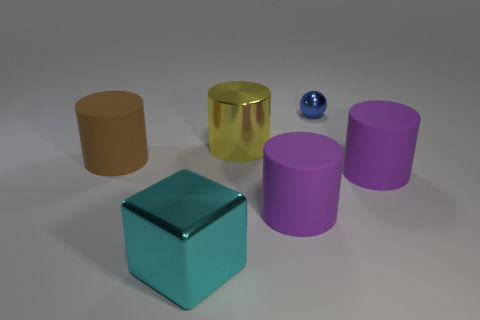Subtract all brown cylinders. How many cylinders are left? 3 Subtract 3 cylinders. How many cylinders are left? 1 Add 4 small yellow matte cylinders. How many objects exist? 10 Subtract all brown cylinders. How many cylinders are left? 3 Subtract all purple cylinders. Subtract all large matte cylinders. How many objects are left? 1 Add 5 blocks. How many blocks are left? 6 Add 2 tiny purple metal cylinders. How many tiny purple metal cylinders exist? 2 Subtract 2 purple cylinders. How many objects are left? 4 Subtract all blocks. How many objects are left? 5 Subtract all gray cylinders. Subtract all brown spheres. How many cylinders are left? 4 